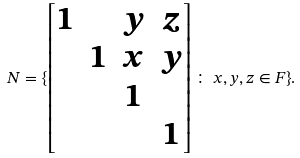Convert formula to latex. <formula><loc_0><loc_0><loc_500><loc_500>N = \{ \begin{bmatrix} 1 & & y & z \\ & 1 & x & y \\ & & 1 \\ & & & 1 \end{bmatrix} \colon \, x , y , z \in F \} .</formula> 